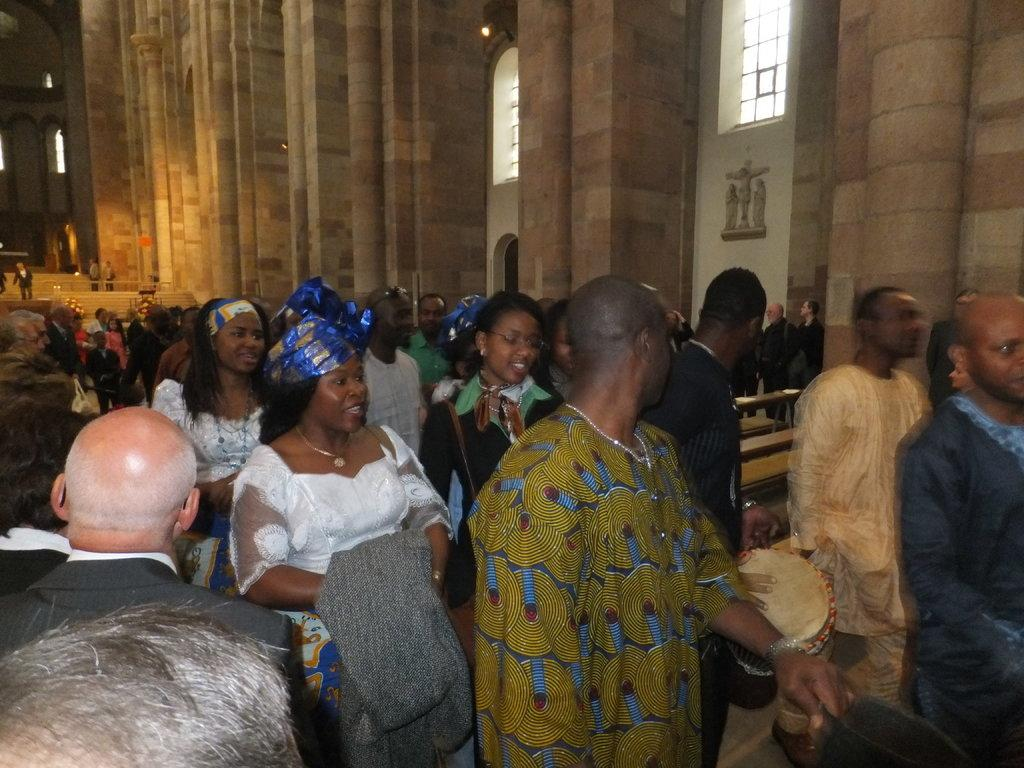How many people can be seen in the image? There are a few people in the image. What is the background of the image? There is a wall in the image. What architectural features are present in the image? There are pillars in the image. What type of seating is available in the image? There are benches in the image. What else can be seen in the image besides the people and the architectural features? There are objects in the image. Can you tell me how many cushions are on the benches in the image? There is no mention of cushions on the benches in the image; only the benches themselves are present. 